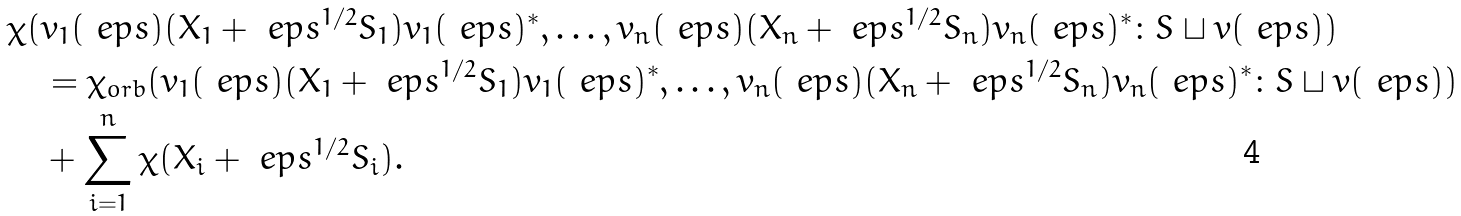Convert formula to latex. <formula><loc_0><loc_0><loc_500><loc_500>& \chi ( v _ { 1 } ( \ e p s ) ( X _ { 1 } + \ e p s ^ { 1 / 2 } S _ { 1 } ) v _ { 1 } ( \ e p s ) ^ { * } , \dots , v _ { n } ( \ e p s ) ( X _ { n } + \ e p s ^ { 1 / 2 } S _ { n } ) v _ { n } ( \ e p s ) ^ { * } \colon S \sqcup v ( \ e p s ) ) \\ & \quad = \chi _ { o r b } ( v _ { 1 } ( \ e p s ) ( X _ { 1 } + \ e p s ^ { 1 / 2 } S _ { 1 } ) v _ { 1 } ( \ e p s ) ^ { * } , \dots , v _ { n } ( \ e p s ) ( X _ { n } + \ e p s ^ { 1 / 2 } S _ { n } ) v _ { n } ( \ e p s ) ^ { * } \colon S \sqcup v ( \ e p s ) ) \\ & \quad + \sum _ { i = 1 } ^ { n } \chi ( X _ { i } + \ e p s ^ { 1 / 2 } S _ { i } ) .</formula> 